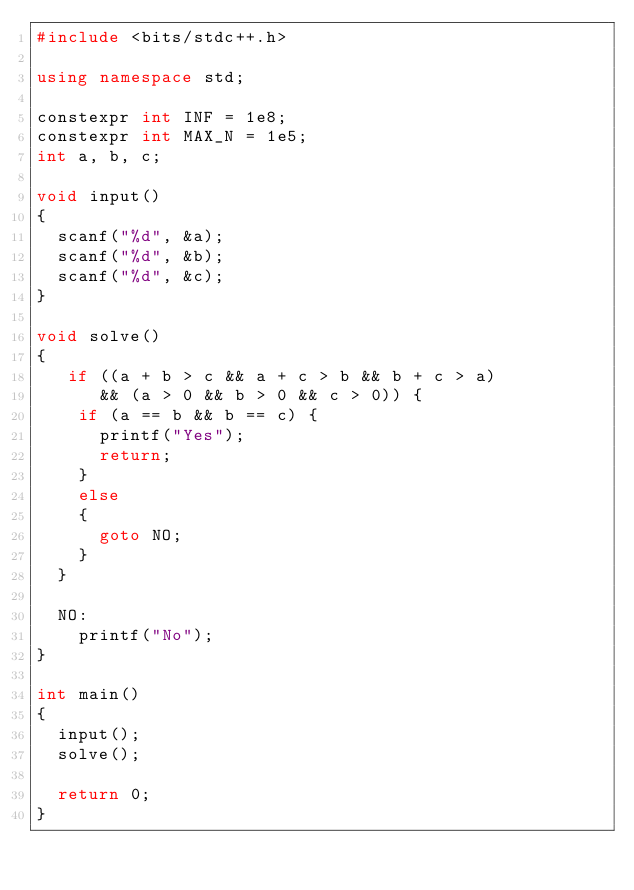Convert code to text. <code><loc_0><loc_0><loc_500><loc_500><_C++_>#include <bits/stdc++.h>

using namespace std;

constexpr int INF = 1e8;
constexpr int MAX_N = 1e5;
int a, b, c;

void input()
{
  scanf("%d", &a);
  scanf("%d", &b);
  scanf("%d", &c);
}

void solve()
{
   if ((a + b > c && a + c > b && b + c > a)
      && (a > 0 && b > 0 && c > 0)) {
    if (a == b && b == c) {
      printf("Yes");
      return;
    }
    else
    {
      goto NO;
    }
  }

  NO:
    printf("No");
}

int main()
{
  input();
  solve();

  return 0;
}</code> 